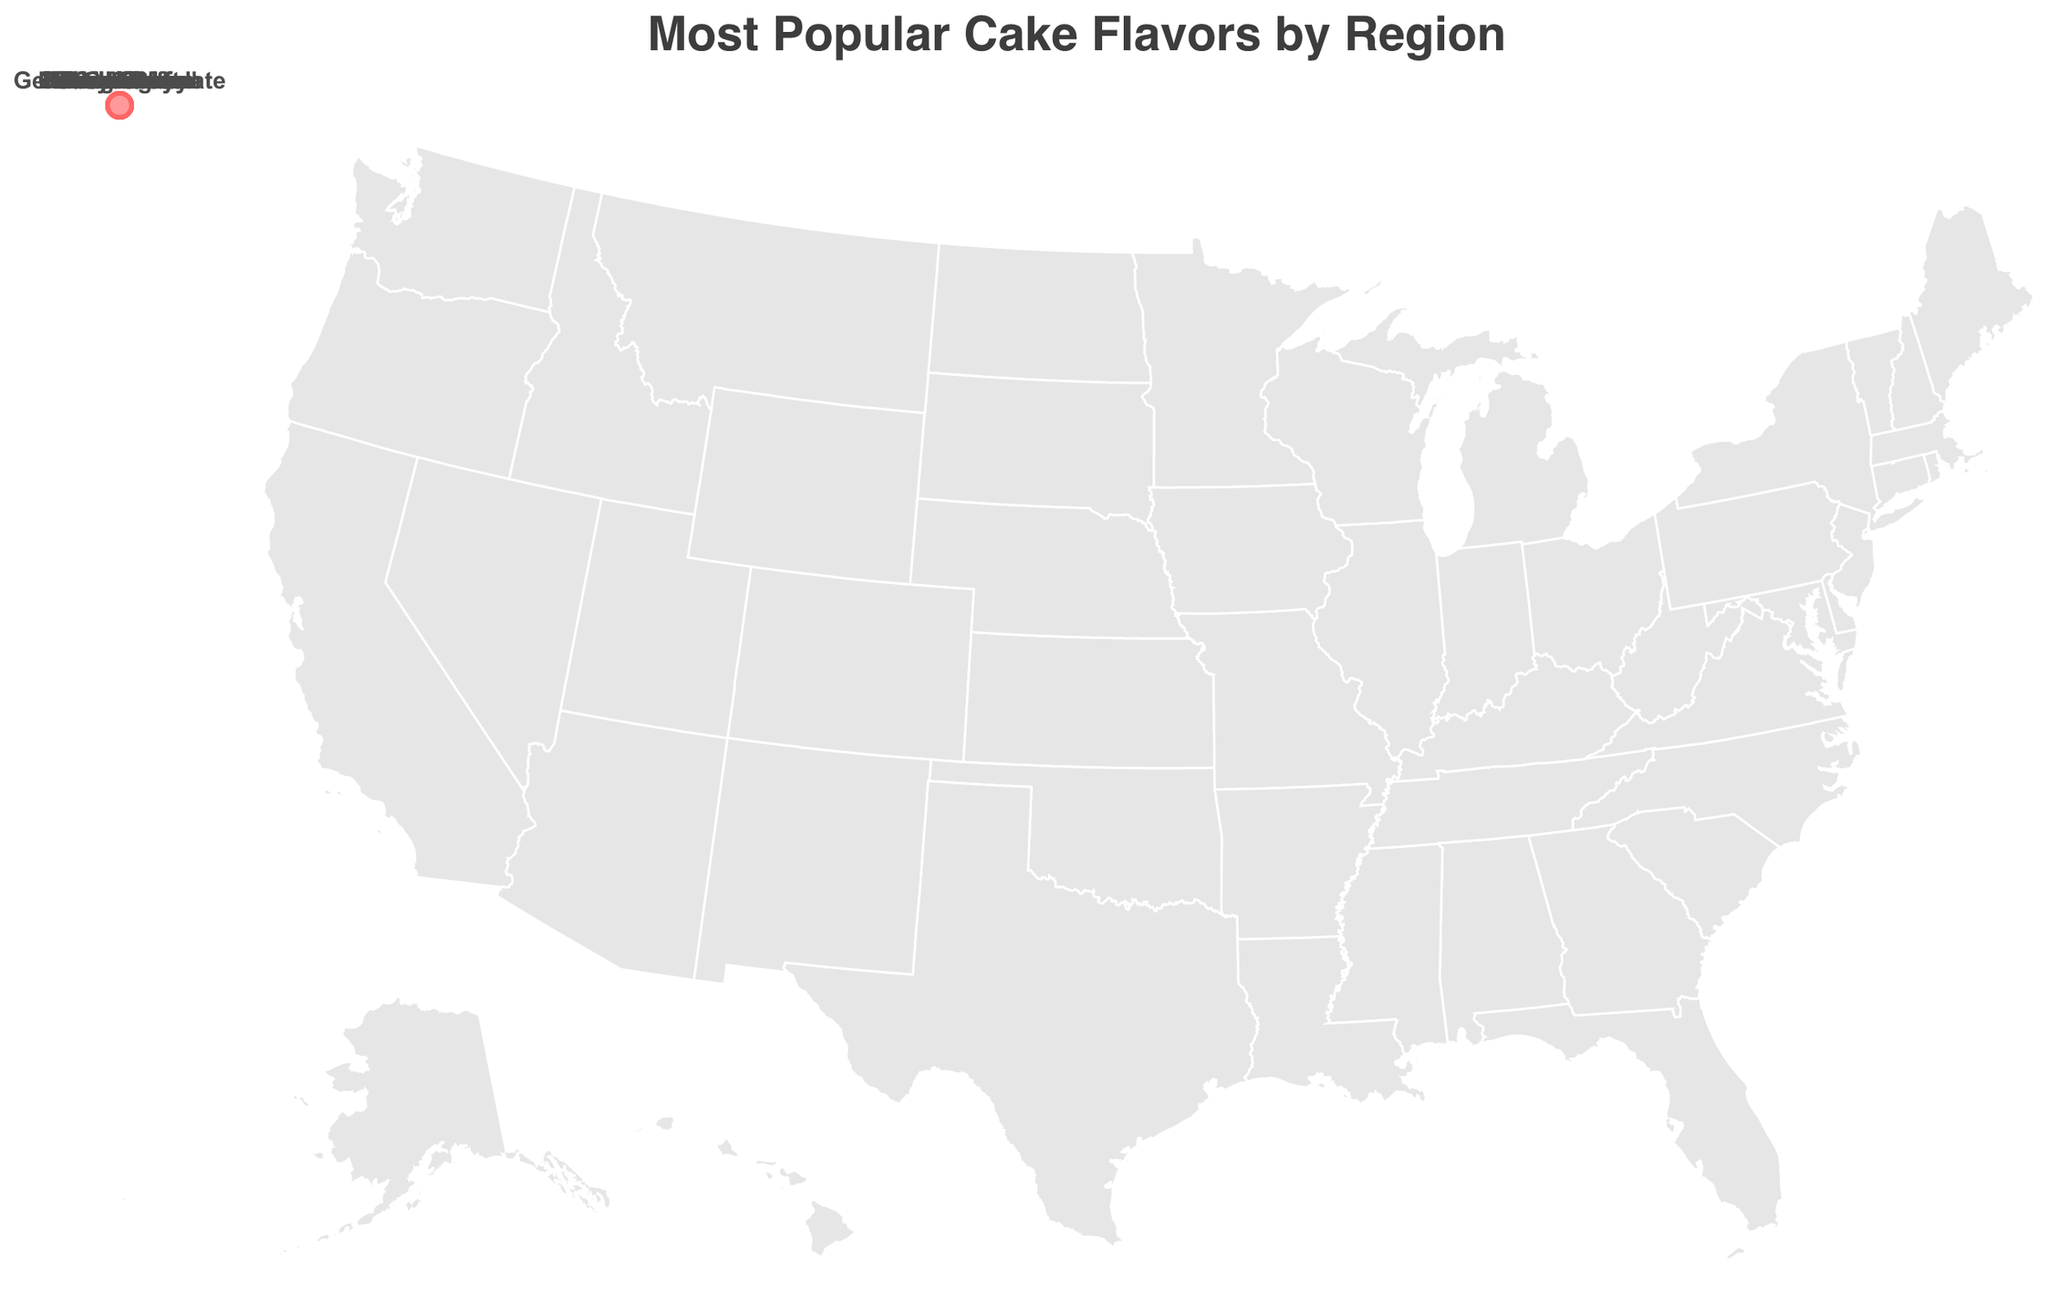What is the title of the figure? The title of the figure can be found at the top and it generally describes what the figure is about. In this case, the title clearly mentions the content of the figure.
Answer: Most Popular Cake Flavors by Region What is the most popular cake flavor in the New England region? Locate the New England region on the geographic plot and refer to the label or text associated with it.
Answer: Boston Cream Which region prefers German Chocolate as the most popular cake flavor? Find the region labeled with "German Chocolate" on the plot to determine which region it corresponds to.
Answer: Rocky Mountains How many different cake flavors are represented in the dataset? By counting the distinct flavors listed for each region, you can determine the total number of unique cake flavors.
Answer: 15 Which region has a preference for Key Lime cake? Search for the region labeled with "Key Lime" on the geographic plot to find the corresponding region.
Answer: Florida Which region's most popular cake flavor is King Cake, and how does it compare to the neighboring regions? Identify the region marked with "King Cake" and look at the neighboring regions to compare their most popular cake flavors.
Answer: Gulf Coast; It is unique compared to the neighboring regions like Southeast (Hummingbird) and Texas (Italian Cream) What is the popular cake flavor on the Gulf Coast? Locate the Gulf Coast region on the map and identify the text label that indicates its most popular cake flavor.
Answer: King Cake Are there any regions that have a berry-flavored cake as their most popular preference? If so, which ones? Scan the plot labels for any mentions of berry-flavored cakes and note their regions.
Answer: Yes; Pacific Northwest (Marionberry) and Alaska (Blueberry) Compare the most popular cake flavors between the Mid-Atlantic and the Pacific Northwest regions. Find the labels for the Mid-Atlantic and Pacific Northwest regions and compare their listed flavors.
Answer: Mid-Atlantic: Red Velvet, Pacific Northwest: Marionberry Name the regions where fruit flavors are the most popular preferences. Identify regions with labels indicating fruit-flavored cakes, such as Marionberry, Lemon, Guava Chiffon, Blueberry, and Key Lime.
Answer: California (Lemon), Hawaii (Guava Chiffon), Alaska (Blueberry), Florida (Key Lime), Pacific Northwest (Marionberry) Which regions have cake preferences that are considered unique and not a common cake flavor in other regions? Look for cake flavors that are specific to one region and not listed elsewhere. Examples are distinct regional specialties or unique flavors.
Answer: Gulf Coast (King Cake), Hawaii (Guava Chiffon), New England (Boston Cream) 